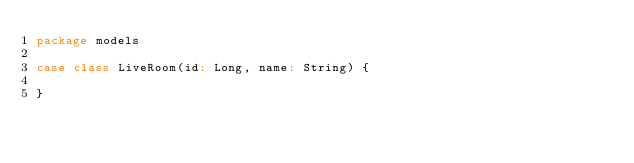Convert code to text. <code><loc_0><loc_0><loc_500><loc_500><_Scala_>package models

case class LiveRoom(id: Long, name: String) {

}
</code> 